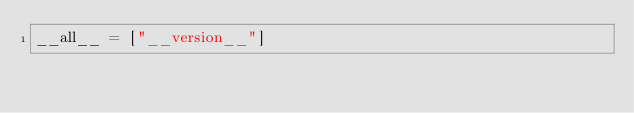Convert code to text. <code><loc_0><loc_0><loc_500><loc_500><_Python_>__all__ = ["__version__"]
</code> 